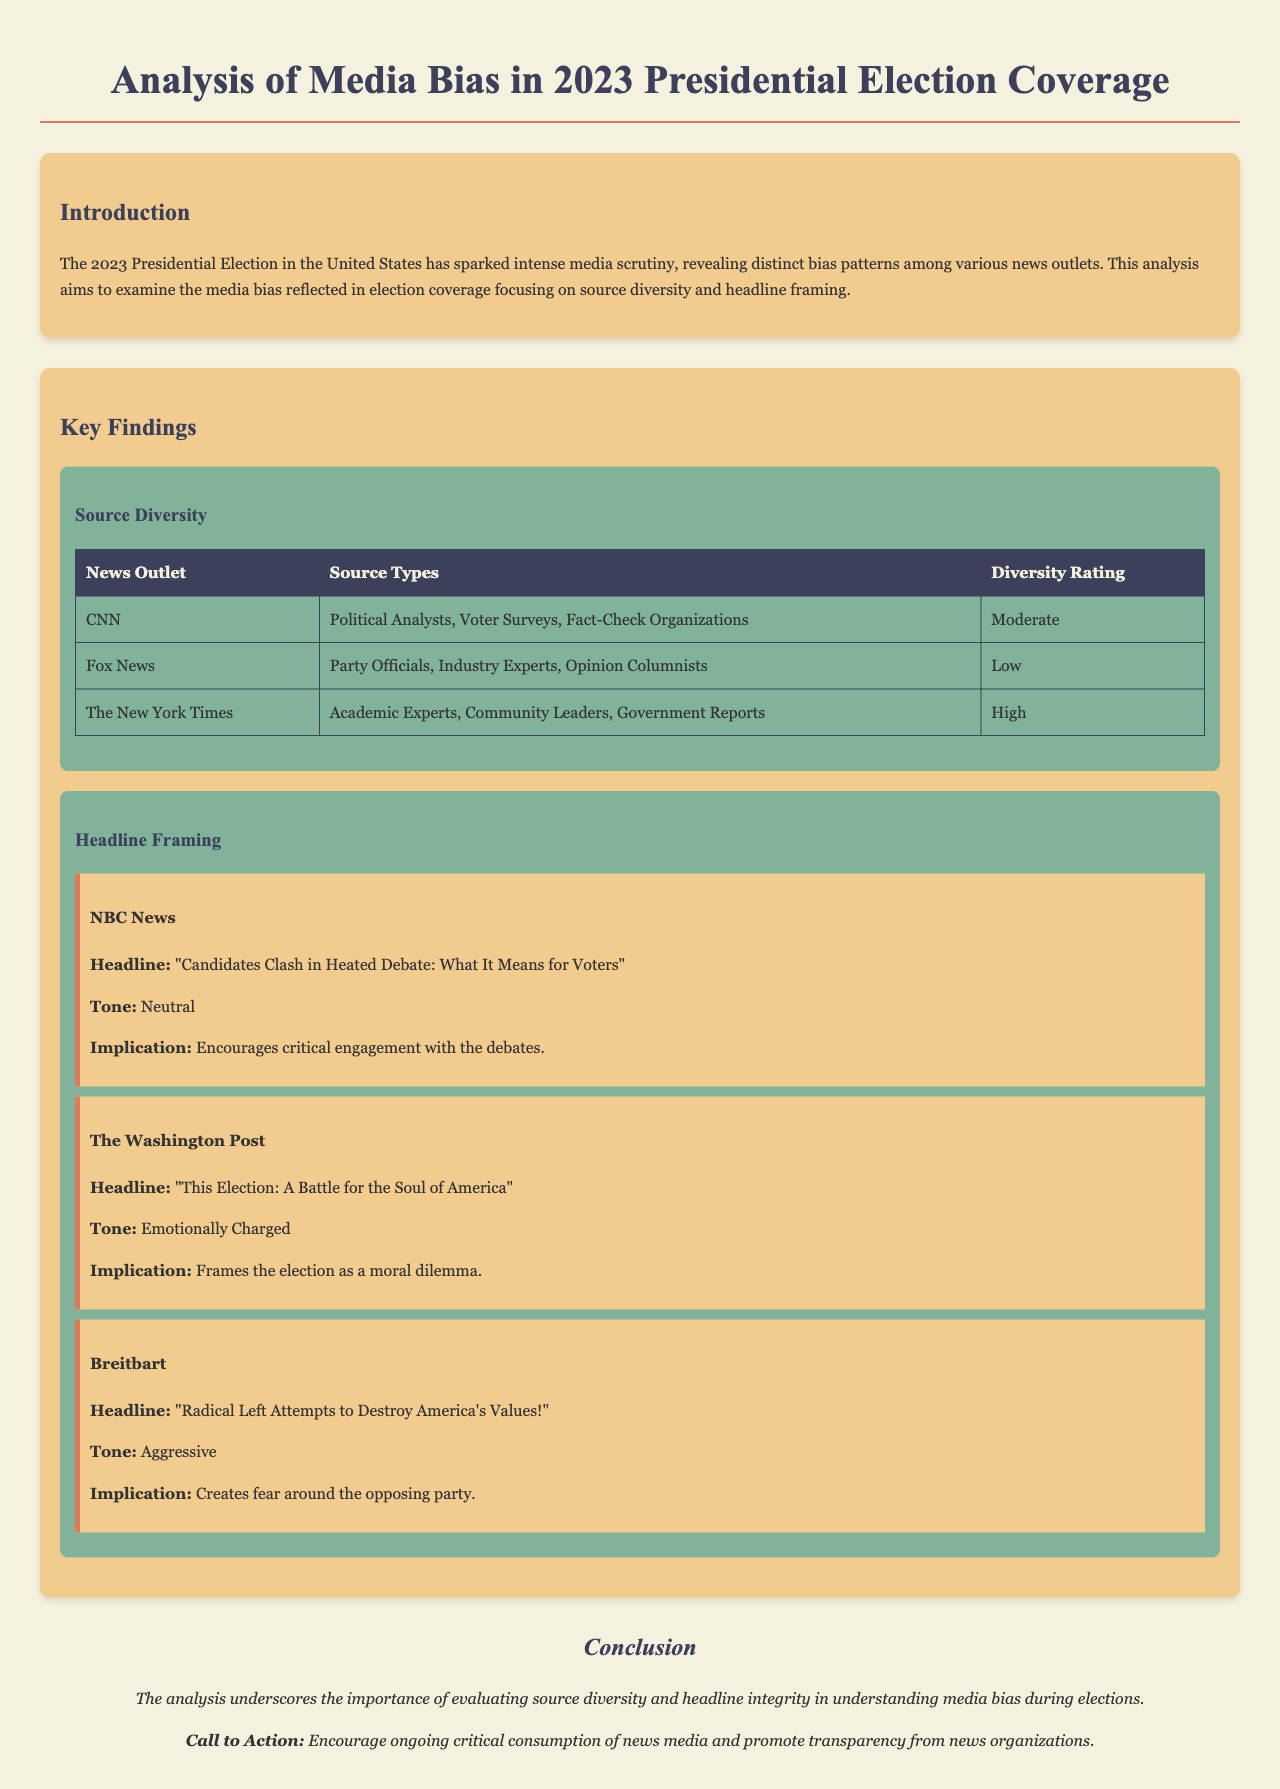What is the title of the document? The title of the document is mentioned in the `<title>` tag of the HTML, which indicates the main focus of the analysis.
Answer: Media Bias Analysis: 2023 Presidential Election Which news outlet received a 'High' diversity rating? The document lists diversity ratings in the 'Source Diversity' section, showing which news outlets have varying degrees of source diversity.
Answer: The New York Times What is the tone of the headline presented by NBC News? The tone is specified within the example for NBC News, describing how the headline is framed.
Answer: Neutral How many source types are listed for Fox News? The document displays the number of different source types associated with each news outlet in the table.
Answer: Three What implication does The Washington Post's headline suggest? The document explains the implications of each headline presented, particularly in the context of the framing and tone.
Answer: Frames the election as a moral dilemma What is the main focus of this analysis? The introduction outlines the primary goal of the analysis, highlighting the aspects being looked into regarding media bias.
Answer: Media bias in election coverage Which news outlet's headline is described as 'Aggressive'? The tone of the headlines is categorized in the 'Headline Framing' section, identifying the styles of various news outlets.
Answer: Breitbart What is the call to action presented in the conclusion? The conclusion summarizes the document's themes and encourages a specific action for the audience.
Answer: Encourage ongoing critical consumption of news media 